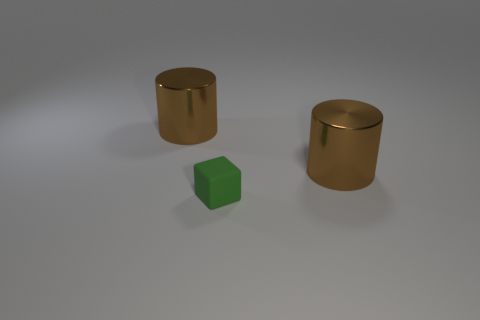Add 3 small green cubes. How many objects exist? 6 Subtract all purple cylinders. Subtract all green blocks. How many cylinders are left? 2 Subtract all red cylinders. How many brown blocks are left? 0 Subtract all large brown cylinders. Subtract all tiny cubes. How many objects are left? 0 Add 2 brown cylinders. How many brown cylinders are left? 4 Add 1 big yellow metal balls. How many big yellow metal balls exist? 1 Subtract 0 gray spheres. How many objects are left? 3 Subtract all cylinders. How many objects are left? 1 